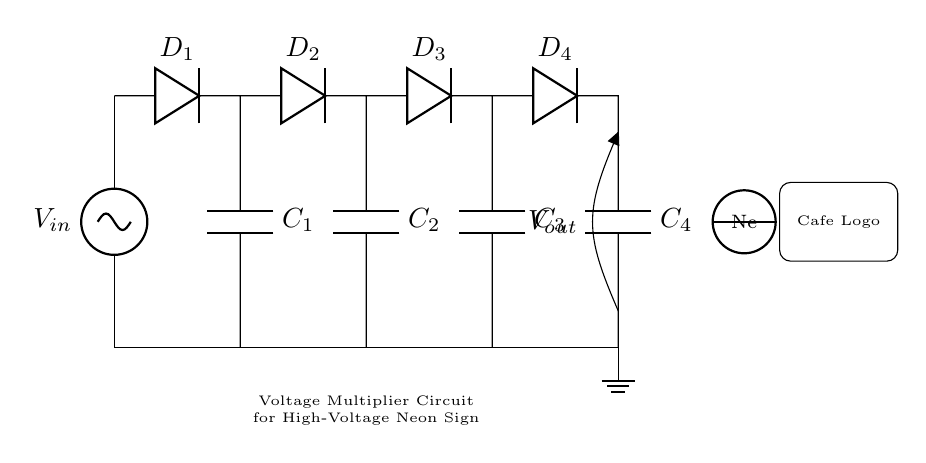What is the purpose of this circuit? The purpose of this circuit is to multiply voltage to generate high voltage suitable for neon signs. This is indicated by the title annotation specifying it is a "Voltage Multiplier Circuit for High-Voltage Neon Sign."
Answer: Voltage Multiplier How many diodes are present in the circuit? By counting the diodes labeled in the circuit diagram, there are a total of four diodes identified as D1, D2, D3, and D4.
Answer: Four What are the capacitor values in this circuit? The circuit diagram does not specify numeric values for the capacitors; they are labeled as C1, C2, C3, and C4.
Answer: C1, C2, C3, C4 What type of circuit is this? This circuit is identified as a rectifier because it converts alternating current (AC) into direct current (DC) by using diodes to allow current to pass in only one direction.
Answer: Rectifier What is the output voltage of this circuit generally used for? Generally, the output voltage is used to energize high-voltage neon signs, which require a specific high voltage to operate correctly. This is implied as the circuit is designed for neon signs.
Answer: Neon Signs 